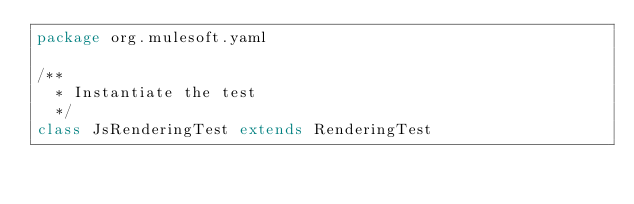Convert code to text. <code><loc_0><loc_0><loc_500><loc_500><_Scala_>package org.mulesoft.yaml

/**
  * Instantiate the test
  */
class JsRenderingTest extends RenderingTest
</code> 